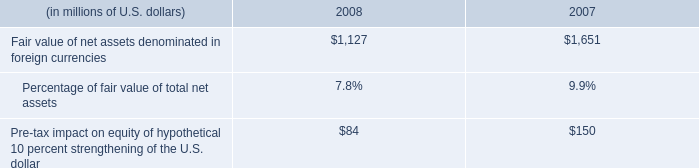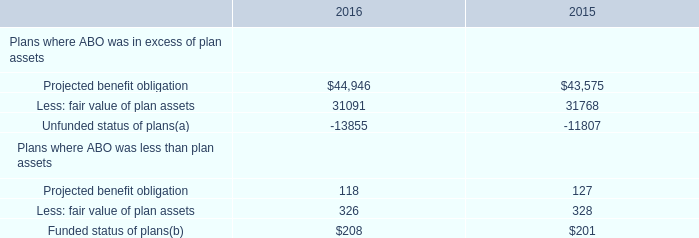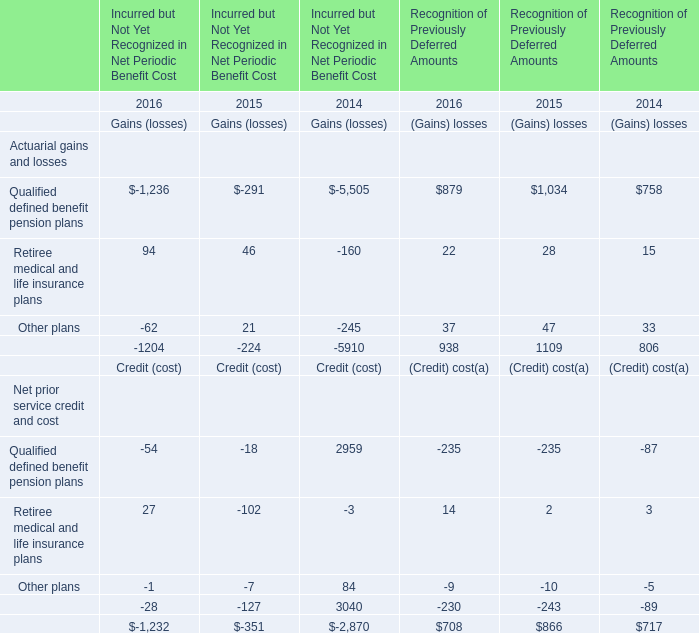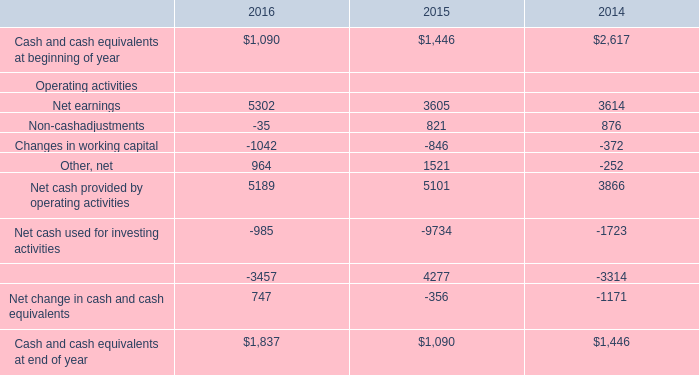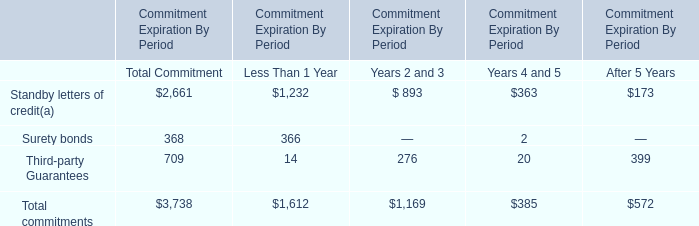what's the total amount of Projected benefit obligation of 2016, and Net earnings Operating activities of 2014 ? 
Computations: (44946.0 + 3614.0)
Answer: 48560.0. 